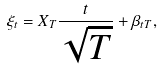Convert formula to latex. <formula><loc_0><loc_0><loc_500><loc_500>\xi _ { t } = X _ { T } \frac { t } { \sqrt { T } } + \beta _ { t T } ,</formula> 